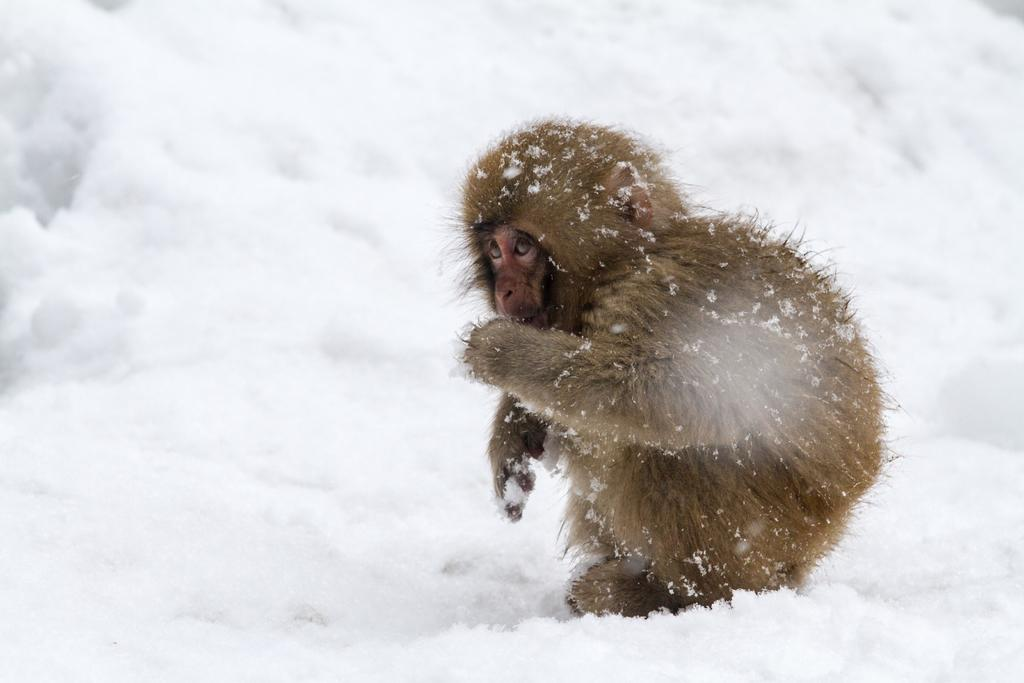What animal is present in the image? There is a monkey in the image. What is the monkey sitting on? The monkey is sitting on the snow. In which direction is the monkey facing? The monkey is facing towards the left side. How is the monkey's body affected by its surroundings? The monkey's body is covered in snow. What type of twist can be seen in the monkey's pocket in the image? There is no twist or pocket present on the monkey in the image. 